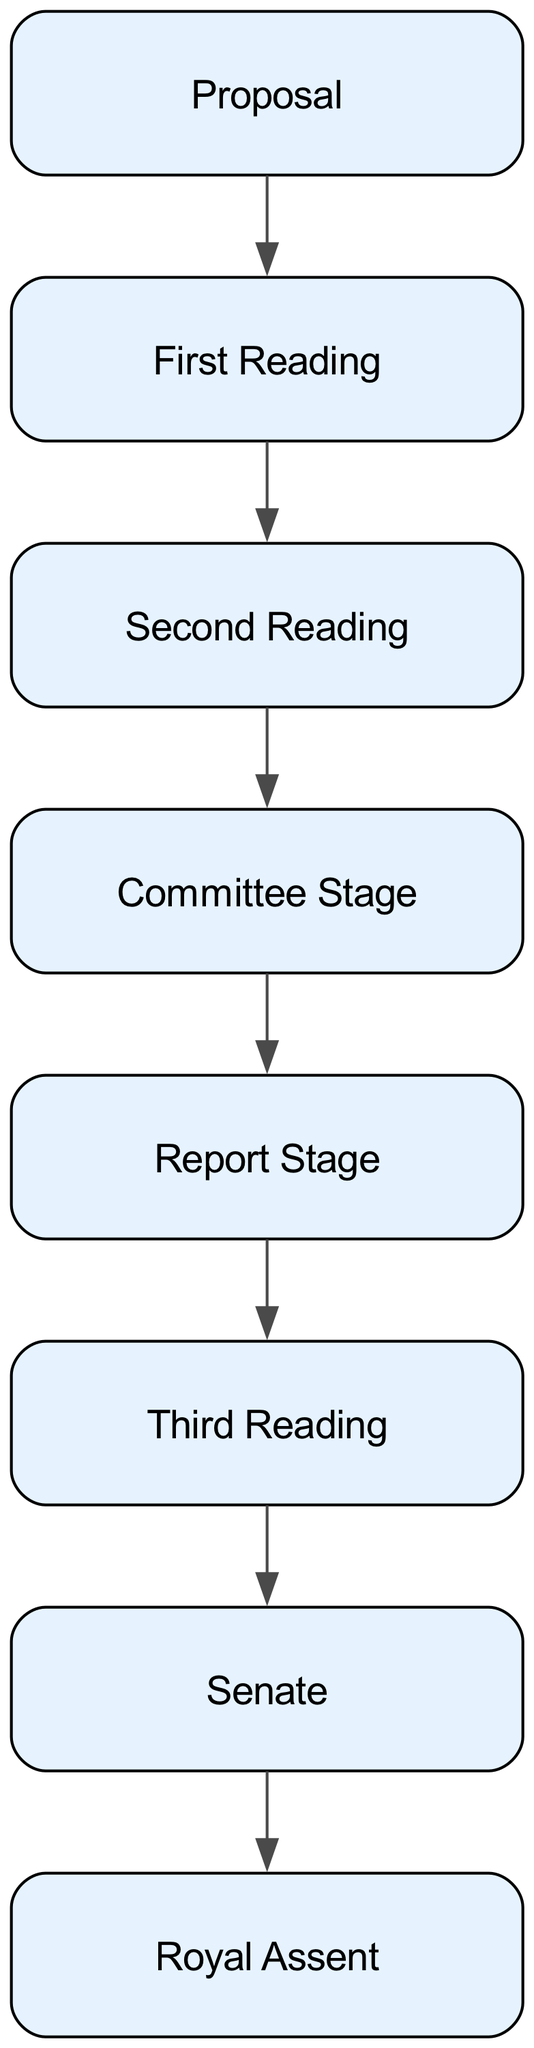What is the first step in the process? The first node in the flow chart is "Proposal," which indicates that the process starts with a member proposing a bill. Therefore, the first step is the proposal of a bill by a Member of Parliament or Senator.
Answer: Proposal How many stages are there before Royal Assent? The diagram outlines several stages before reaching Royal Assent: Proposal, First Reading, Second Reading, Committee Stage, Report Stage, Third Reading, and the Senate stages. Counting these, there are six stages before Royal Assent.
Answer: Six What happens after the Committee Stage? After the Committee Stage, the diagram shows the next step is the Report Stage, where amendments made by the committee are reported back to the whole House for further consideration.
Answer: Report Stage Which stage involves detailed examination and amendments? The Committee Stage is explicitly mentioned as the stage where the bill undergoes detailed examination by a parliamentary committee, and amendments can be made to its content.
Answer: Committee Stage In which House does the bill undergo the First Reading? The First Reading occurs in either the House of Commons or the Senate. Since the question is about identifying the House, it can be either one, but typically it starts in the House of Commons if it's a government bill.
Answer: House of Commons (or Senate) What is the last step before a bill becomes law? The last step shown in the diagram is Royal Assent, which is granted if both Houses approve the bill, marking the final step before it becomes law. This signifies the culmination of the legislative process.
Answer: Royal Assent How many readings does a bill go through in the Senate? The bill goes through the same stages in the Senate as in the House, which includes First Reading, Second Reading, Committee Stage, Report Stage, and Third Reading. Counting these, there are five readings in the Senate.
Answer: Five What occurs during the Third Reading? The Third Reading is the stage where there is a debate and vote on the final form of the bill. If it passes at this stage, it moves to the other House for further consideration. This signifies the final opportunity to discuss the bill before it potentially passes.
Answer: Debate and vote 